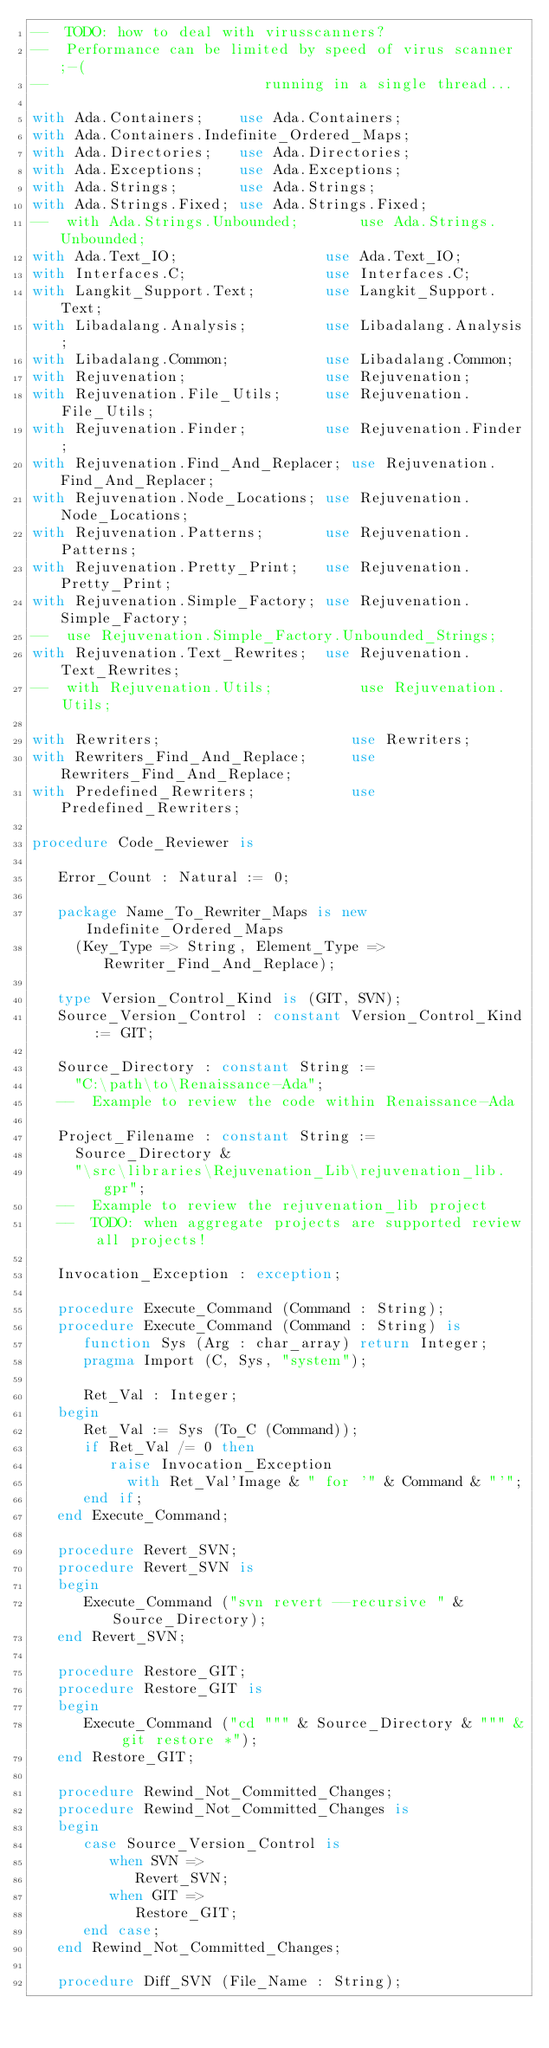<code> <loc_0><loc_0><loc_500><loc_500><_Ada_>--  TODO: how to deal with virusscanners?
--  Performance can be limited by speed of virus scanner ;-(
--                         running in a single thread...

with Ada.Containers;    use Ada.Containers;
with Ada.Containers.Indefinite_Ordered_Maps;
with Ada.Directories;   use Ada.Directories;
with Ada.Exceptions;    use Ada.Exceptions;
with Ada.Strings;       use Ada.Strings;
with Ada.Strings.Fixed; use Ada.Strings.Fixed;
--  with Ada.Strings.Unbounded;       use Ada.Strings.Unbounded;
with Ada.Text_IO;                 use Ada.Text_IO;
with Interfaces.C;                use Interfaces.C;
with Langkit_Support.Text;        use Langkit_Support.Text;
with Libadalang.Analysis;         use Libadalang.Analysis;
with Libadalang.Common;           use Libadalang.Common;
with Rejuvenation;                use Rejuvenation;
with Rejuvenation.File_Utils;     use Rejuvenation.File_Utils;
with Rejuvenation.Finder;         use Rejuvenation.Finder;
with Rejuvenation.Find_And_Replacer; use Rejuvenation.Find_And_Replacer;
with Rejuvenation.Node_Locations; use Rejuvenation.Node_Locations;
with Rejuvenation.Patterns;       use Rejuvenation.Patterns;
with Rejuvenation.Pretty_Print;   use Rejuvenation.Pretty_Print;
with Rejuvenation.Simple_Factory; use Rejuvenation.Simple_Factory;
--  use Rejuvenation.Simple_Factory.Unbounded_Strings;
with Rejuvenation.Text_Rewrites;  use Rejuvenation.Text_Rewrites;
--  with Rejuvenation.Utils;          use Rejuvenation.Utils;

with Rewriters;                      use Rewriters;
with Rewriters_Find_And_Replace;     use Rewriters_Find_And_Replace;
with Predefined_Rewriters;           use Predefined_Rewriters;

procedure Code_Reviewer is

   Error_Count : Natural := 0;

   package Name_To_Rewriter_Maps is new Indefinite_Ordered_Maps
     (Key_Type => String, Element_Type => Rewriter_Find_And_Replace);

   type Version_Control_Kind is (GIT, SVN);
   Source_Version_Control : constant Version_Control_Kind := GIT;

   Source_Directory : constant String :=
     "C:\path\to\Renaissance-Ada";
   --  Example to review the code within Renaissance-Ada

   Project_Filename : constant String :=
     Source_Directory &
     "\src\libraries\Rejuvenation_Lib\rejuvenation_lib.gpr";
   --  Example to review the rejuvenation_lib project
   --  TODO: when aggregate projects are supported review all projects!

   Invocation_Exception : exception;

   procedure Execute_Command (Command : String);
   procedure Execute_Command (Command : String) is
      function Sys (Arg : char_array) return Integer;
      pragma Import (C, Sys, "system");

      Ret_Val : Integer;
   begin
      Ret_Val := Sys (To_C (Command));
      if Ret_Val /= 0 then
         raise Invocation_Exception
           with Ret_Val'Image & " for '" & Command & "'";
      end if;
   end Execute_Command;

   procedure Revert_SVN;
   procedure Revert_SVN is
   begin
      Execute_Command ("svn revert --recursive " & Source_Directory);
   end Revert_SVN;

   procedure Restore_GIT;
   procedure Restore_GIT is
   begin
      Execute_Command ("cd """ & Source_Directory & """ & git restore *");
   end Restore_GIT;

   procedure Rewind_Not_Committed_Changes;
   procedure Rewind_Not_Committed_Changes is
   begin
      case Source_Version_Control is
         when SVN =>
            Revert_SVN;
         when GIT =>
            Restore_GIT;
      end case;
   end Rewind_Not_Committed_Changes;

   procedure Diff_SVN (File_Name : String);</code> 